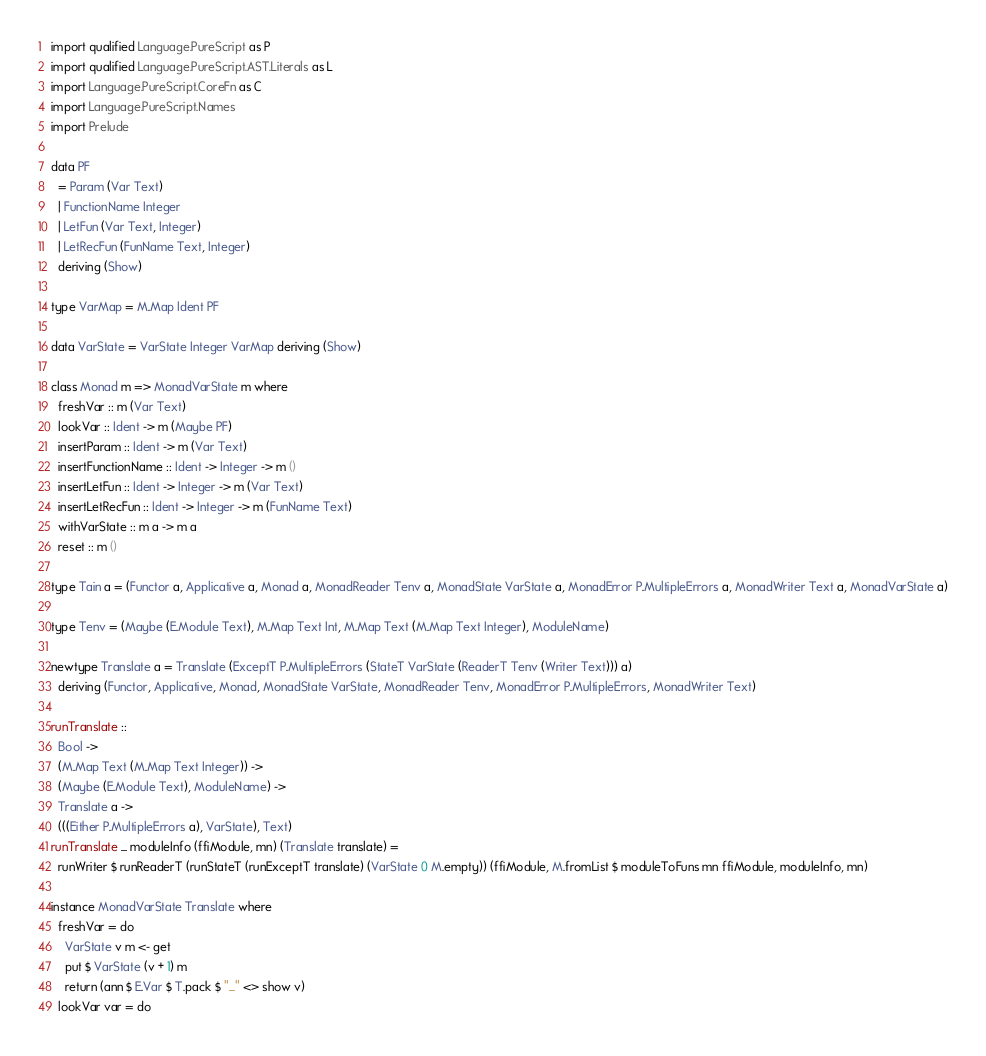Convert code to text. <code><loc_0><loc_0><loc_500><loc_500><_Haskell_>import qualified Language.PureScript as P
import qualified Language.PureScript.AST.Literals as L
import Language.PureScript.CoreFn as C
import Language.PureScript.Names
import Prelude

data PF
  = Param (Var Text)
  | FunctionName Integer
  | LetFun (Var Text, Integer)
  | LetRecFun (FunName Text, Integer)
  deriving (Show)

type VarMap = M.Map Ident PF

data VarState = VarState Integer VarMap deriving (Show)

class Monad m => MonadVarState m where
  freshVar :: m (Var Text)
  lookVar :: Ident -> m (Maybe PF)
  insertParam :: Ident -> m (Var Text)
  insertFunctionName :: Ident -> Integer -> m ()
  insertLetFun :: Ident -> Integer -> m (Var Text)
  insertLetRecFun :: Ident -> Integer -> m (FunName Text)
  withVarState :: m a -> m a
  reset :: m ()

type Tain a = (Functor a, Applicative a, Monad a, MonadReader Tenv a, MonadState VarState a, MonadError P.MultipleErrors a, MonadWriter Text a, MonadVarState a)

type Tenv = (Maybe (E.Module Text), M.Map Text Int, M.Map Text (M.Map Text Integer), ModuleName)

newtype Translate a = Translate (ExceptT P.MultipleErrors (StateT VarState (ReaderT Tenv (Writer Text))) a)
  deriving (Functor, Applicative, Monad, MonadState VarState, MonadReader Tenv, MonadError P.MultipleErrors, MonadWriter Text)

runTranslate ::
  Bool ->
  (M.Map Text (M.Map Text Integer)) ->
  (Maybe (E.Module Text), ModuleName) ->
  Translate a ->
  (((Either P.MultipleErrors a), VarState), Text)
runTranslate _ moduleInfo (ffiModule, mn) (Translate translate) =
  runWriter $ runReaderT (runStateT (runExceptT translate) (VarState 0 M.empty)) (ffiModule, M.fromList $ moduleToFuns mn ffiModule, moduleInfo, mn)

instance MonadVarState Translate where
  freshVar = do
    VarState v m <- get
    put $ VarState (v + 1) m
    return (ann $ E.Var $ T.pack $ "_" <> show v)
  lookVar var = do</code> 